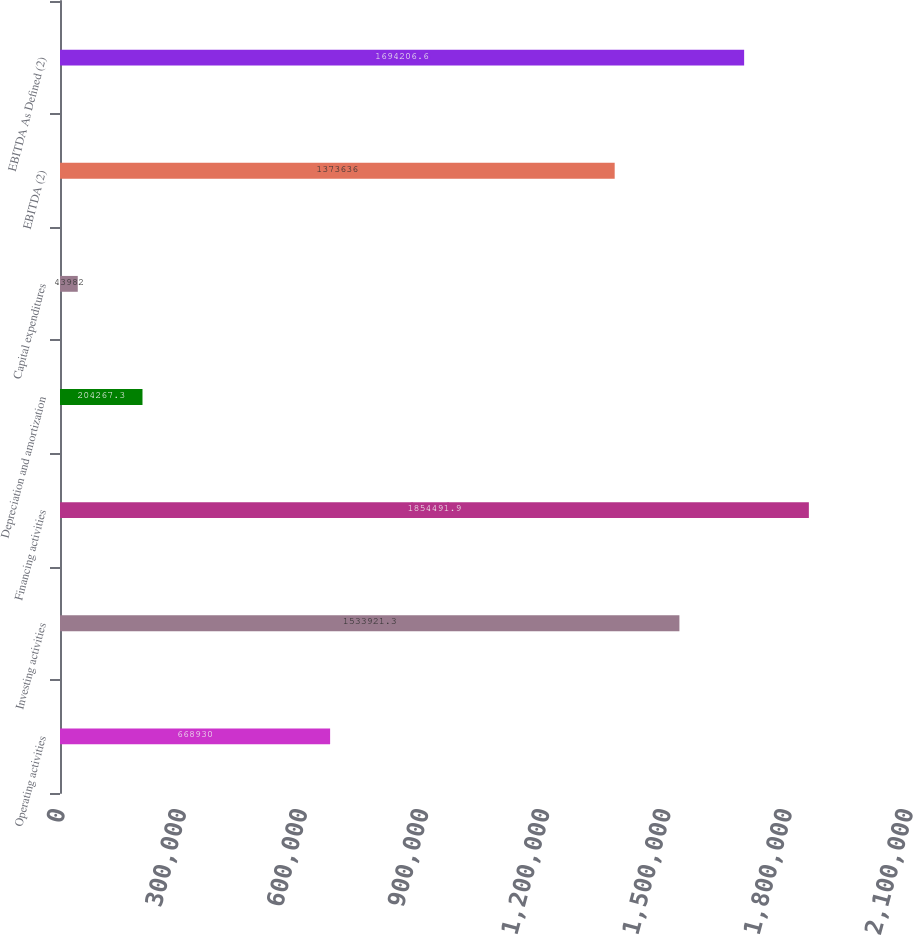Convert chart to OTSL. <chart><loc_0><loc_0><loc_500><loc_500><bar_chart><fcel>Operating activities<fcel>Investing activities<fcel>Financing activities<fcel>Depreciation and amortization<fcel>Capital expenditures<fcel>EBITDA (2)<fcel>EBITDA As Defined (2)<nl><fcel>668930<fcel>1.53392e+06<fcel>1.85449e+06<fcel>204267<fcel>43982<fcel>1.37364e+06<fcel>1.69421e+06<nl></chart> 